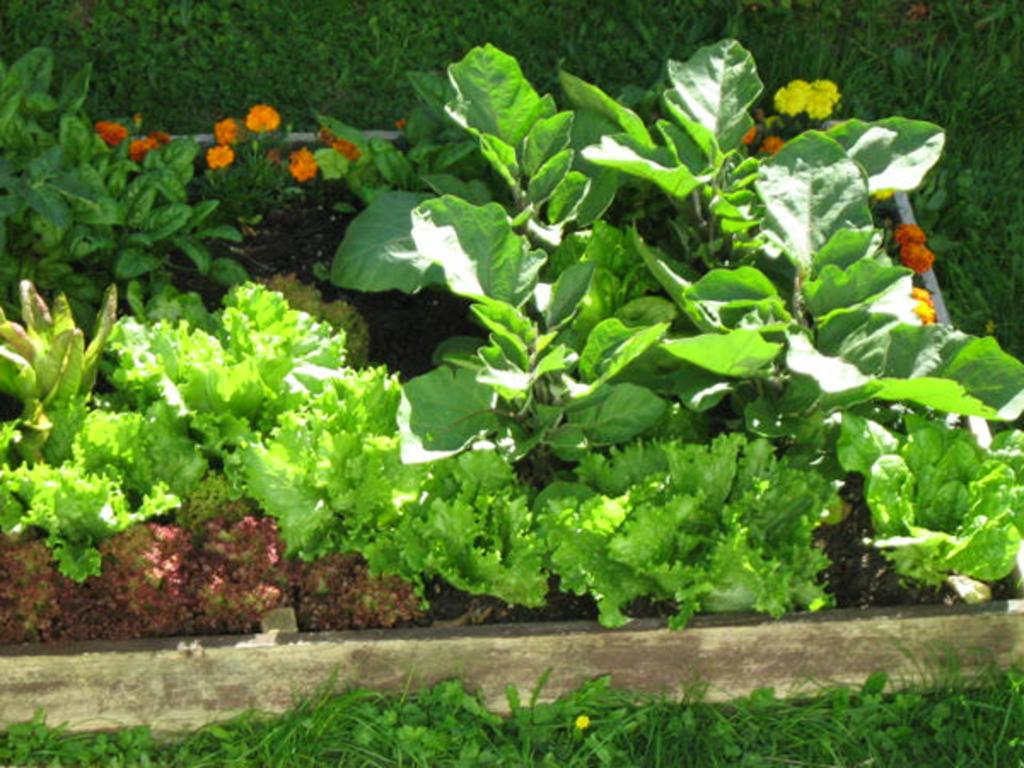What types of flora are present in the image? There are flowers and plants in the image. How are the flowers and plants arranged in the image? The flowers and plants are arranged from left to right in the image. What type of crown can be seen on the rose in the image? There is no rose or crown present in the image; it features flowers and plants arranged from left to right. 